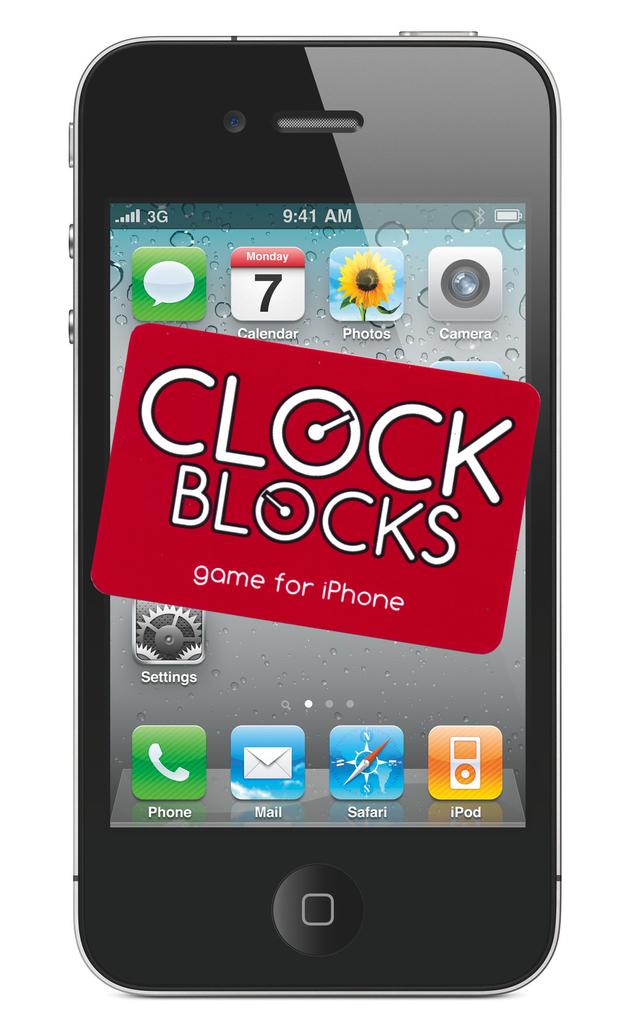What is the app shown on this phone?
Your answer should be very brief. Clock blocks. What does clock blocks do as an app?
Make the answer very short. Game. 